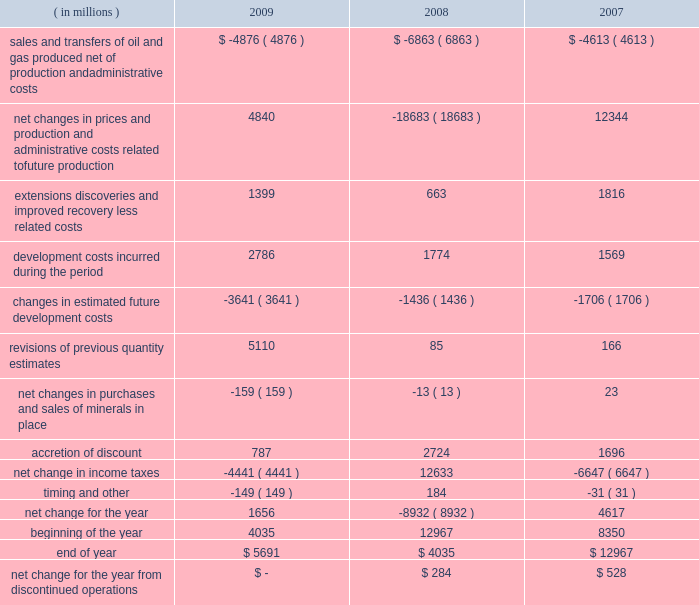Supplementary information on oil and gas producing activities ( unaudited ) changes in the standardized measure of discounted future net cash flows .

Were total revisions of estimates greater than accretion of discounts? 
Computations: greater(table_sum(revisions of previous quantity estimates, none), table_sum(accretion of discount, none))
Answer: yes. 